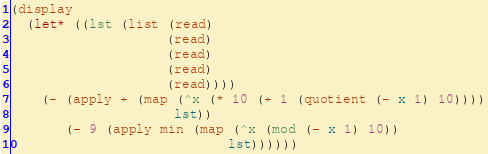Convert code to text. <code><loc_0><loc_0><loc_500><loc_500><_Scheme_>(display
  (let* ((lst (list (read)
                    (read)
                    (read)
                    (read)
                    (read))))
    (- (apply + (map (^x (* 10 (+ 1 (quotient (- x 1) 10))))
                     lst))
       (- 9 (apply min (map (^x (mod (- x 1) 10))
                            lst))))))
</code> 